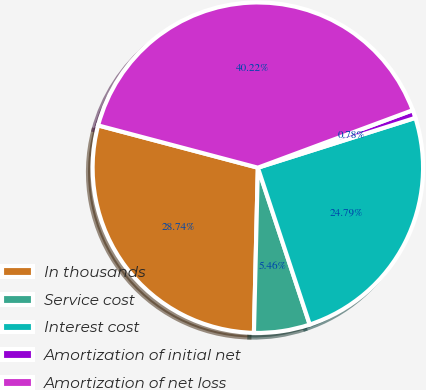<chart> <loc_0><loc_0><loc_500><loc_500><pie_chart><fcel>In thousands<fcel>Service cost<fcel>Interest cost<fcel>Amortization of initial net<fcel>Amortization of net loss<nl><fcel>28.74%<fcel>5.46%<fcel>24.79%<fcel>0.78%<fcel>40.22%<nl></chart> 